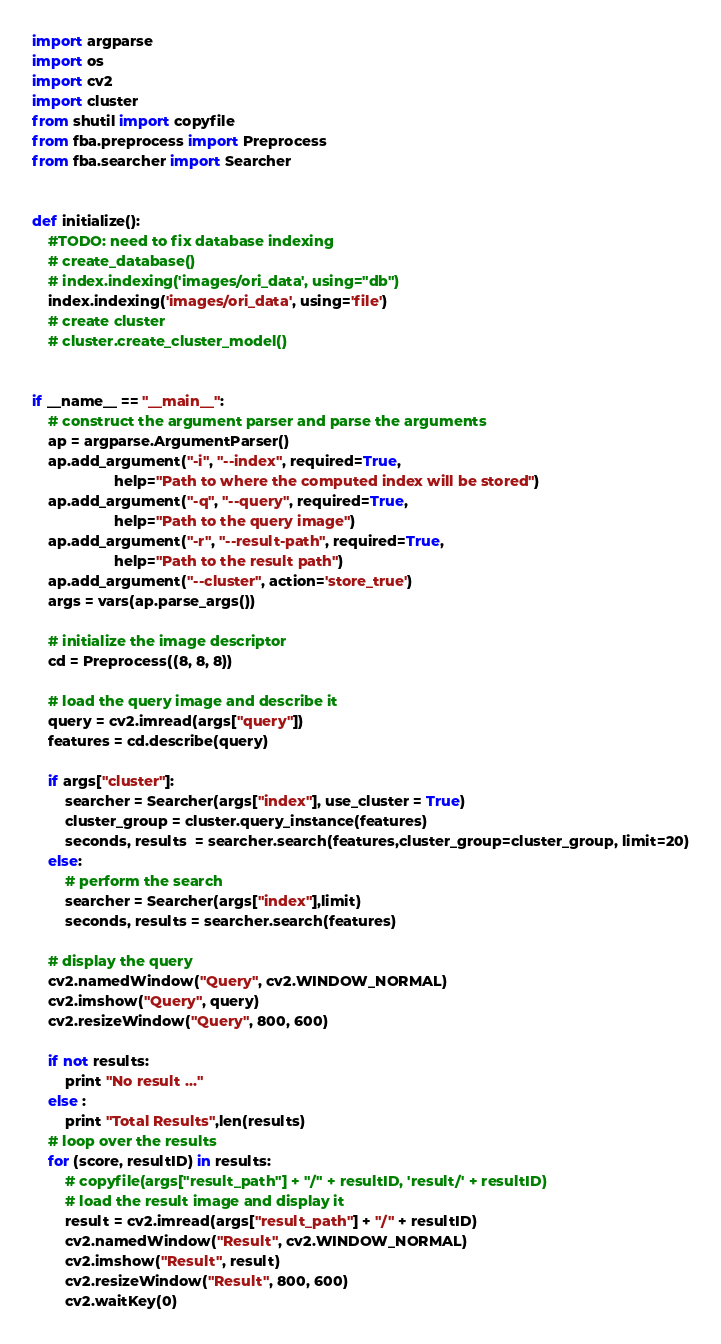<code> <loc_0><loc_0><loc_500><loc_500><_Python_>import argparse
import os
import cv2
import cluster
from shutil import copyfile
from fba.preprocess import Preprocess
from fba.searcher import Searcher


def initialize():
    #TODO: need to fix database indexing
    # create_database()
    # index.indexing('images/ori_data', using="db")
    index.indexing('images/ori_data', using='file')
    # create cluster
    # cluster.create_cluster_model()


if __name__ == "__main__":
    # construct the argument parser and parse the arguments
    ap = argparse.ArgumentParser()
    ap.add_argument("-i", "--index", required=True,
                    help="Path to where the computed index will be stored")
    ap.add_argument("-q", "--query", required=True,
                    help="Path to the query image")
    ap.add_argument("-r", "--result-path", required=True,
                    help="Path to the result path")
    ap.add_argument("--cluster", action='store_true')
    args = vars(ap.parse_args())

    # initialize the image descriptor
    cd = Preprocess((8, 8, 8))

    # load the query image and describe it
    query = cv2.imread(args["query"])
    features = cd.describe(query)

    if args["cluster"]:
        searcher = Searcher(args["index"], use_cluster = True)
        cluster_group = cluster.query_instance(features)
        seconds, results  = searcher.search(features,cluster_group=cluster_group, limit=20)
    else:
        # perform the search
        searcher = Searcher(args["index"],limit)
        seconds, results = searcher.search(features)

    # display the query
    cv2.namedWindow("Query", cv2.WINDOW_NORMAL)
    cv2.imshow("Query", query)
    cv2.resizeWindow("Query", 800, 600)

    if not results:
        print "No result ..."
    else :
        print "Total Results",len(results)
    # loop over the results
    for (score, resultID) in results:
        # copyfile(args["result_path"] + "/" + resultID, 'result/' + resultID)
        # load the result image and display it
        result = cv2.imread(args["result_path"] + "/" + resultID)
        cv2.namedWindow("Result", cv2.WINDOW_NORMAL)
        cv2.imshow("Result", result)
        cv2.resizeWindow("Result", 800, 600)
        cv2.waitKey(0)
</code> 